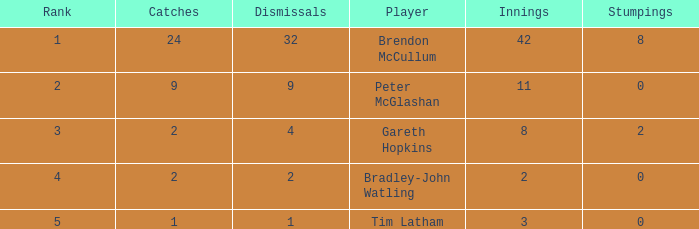How many innings had a total of 2 catches and 0 stumpings? 1.0. 